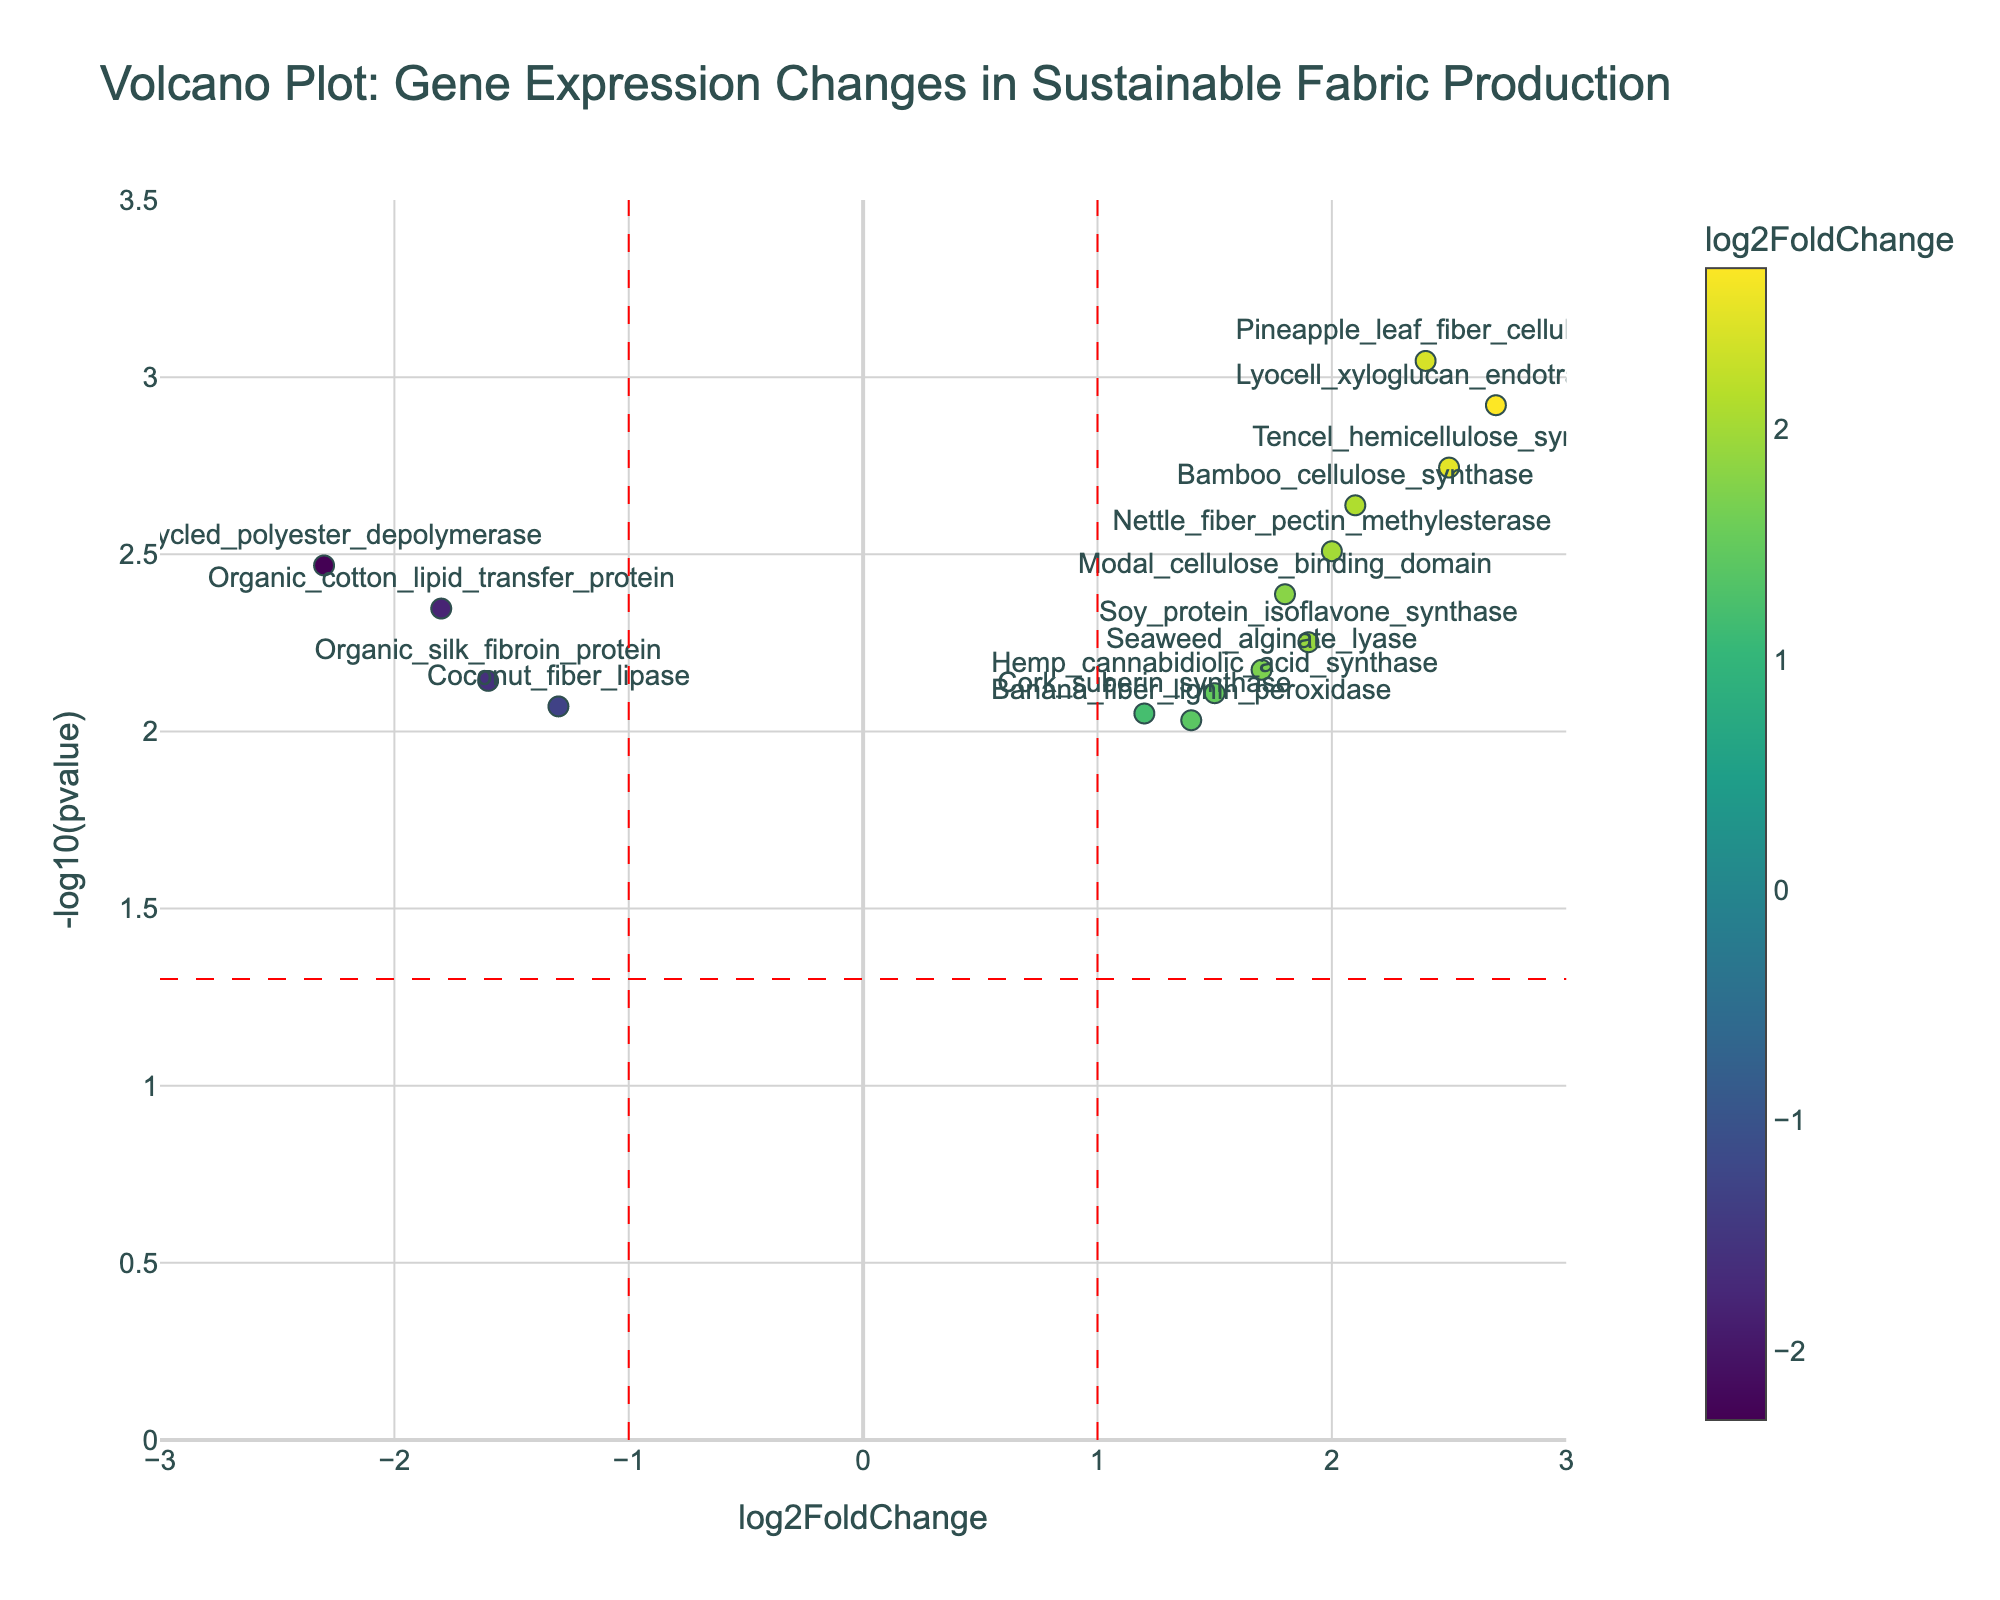Which gene has the highest -log10(pvalue)? To find the gene with the highest -log10(pvalue), look for the highest point on the y-axis of the plot. The highest point corresponds to a -log10(pvalue) of 3.0458. The gene at this point is Pineapple_leaf_fiber_cellulase.
Answer: Pineapple_leaf_fiber_cellulase How many genes have a log2FoldChange greater than 2? To determine how many genes have a log2FoldChange greater than 2, count the points to the right of the vertical line at x=2. The genes that fulfill this condition are Bamboo_cellulose_synthase, Lyocell_xyloglucan_endotransglucosylase, Pineapple_leaf_fiber_cellulase, Tencel_hemicellulose_synthase, and Nettle_fiber_pectin_methylesterase. There are a total of 5 such genes.
Answer: 5 Which gene has the most negative log2FoldChange and is it statistically significant? Identify the gene with the most negative log2FoldChange by looking for the point furthest left on the x-axis. The gene with the most negative log2FoldChange is Recycled_polyester_depolymerase with a log2FoldChange of -2.3. To check statistical significance, see if it is above the horizontal dashed line at y=-log10(0.05), which it is, because -log10(0.0034) equals 2.47.
Answer: Recycled_polyester_depolymerase What is the log2FoldChange of the gene with a p-value of 0.0009? Identify the p-value of 0.0009 by finding the corresponding -log10(pvalue): -log10(0.0009) is 3.0458. The gene with this value is Pineapple_leaf_fiber_cellulase. The log2FoldChange of this gene is 2.4.
Answer: 2.4 How many genes are above the significance threshold (p < 0.05), and have a log2FoldChange outside the range -1 to 1? To find this, count the genes above the horizontal dashed line at y=-log10(0.05) and outside the vertical dashed lines at x=-1 and x=1. These genes are Bamboo_cellulose_synthase, Lyocell_xyloglucan_endotransglucosylase, Recycled_polyester_depolymerase, Pineapple_leaf_fiber_cellulase, Tencel_hemicellulose_synthase, and Organic_cotton_lipid_transfer_protein. There are 6 such genes.
Answer: 6 Which gene has a log2FoldChange of 1.5 and is it statistically significant? To find the gene with a log2FoldChange of 1.5, look for the point at x=1.5 on the plot. The gene is Hemp_cannabidiolic_acid_synthase. To check if it is statistically significant, verify if it is above the horizontal dashed line at y=-log10(0.05), which it is (-log10(0.0078) equals 2.1079).
Answer: Hemp_cannabidiolic_acid_synthase What is the combined log2FoldChange of Bamboo_cellulose_synthase and Organic_cotton_lipid_transfer_protein? Sum the log2FoldChange values of these two genes: Bamboo_cellulose_synthase (2.1) and Organic_cotton_lipid_transfer_protein (-1.8). 2.1 + (-1.8) equals 0.3.
Answer: 0.3 